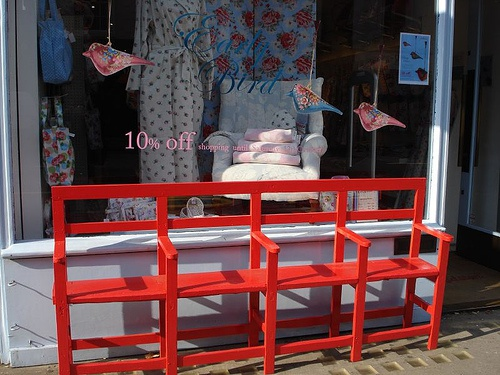Describe the objects in this image and their specific colors. I can see bench in white, brown, darkgray, maroon, and red tones, chair in white, brown, darkgray, gray, and red tones, chair in white, brown, maroon, red, and darkgray tones, chair in white, maroon, black, brown, and red tones, and chair in white, brown, black, gray, and maroon tones in this image. 